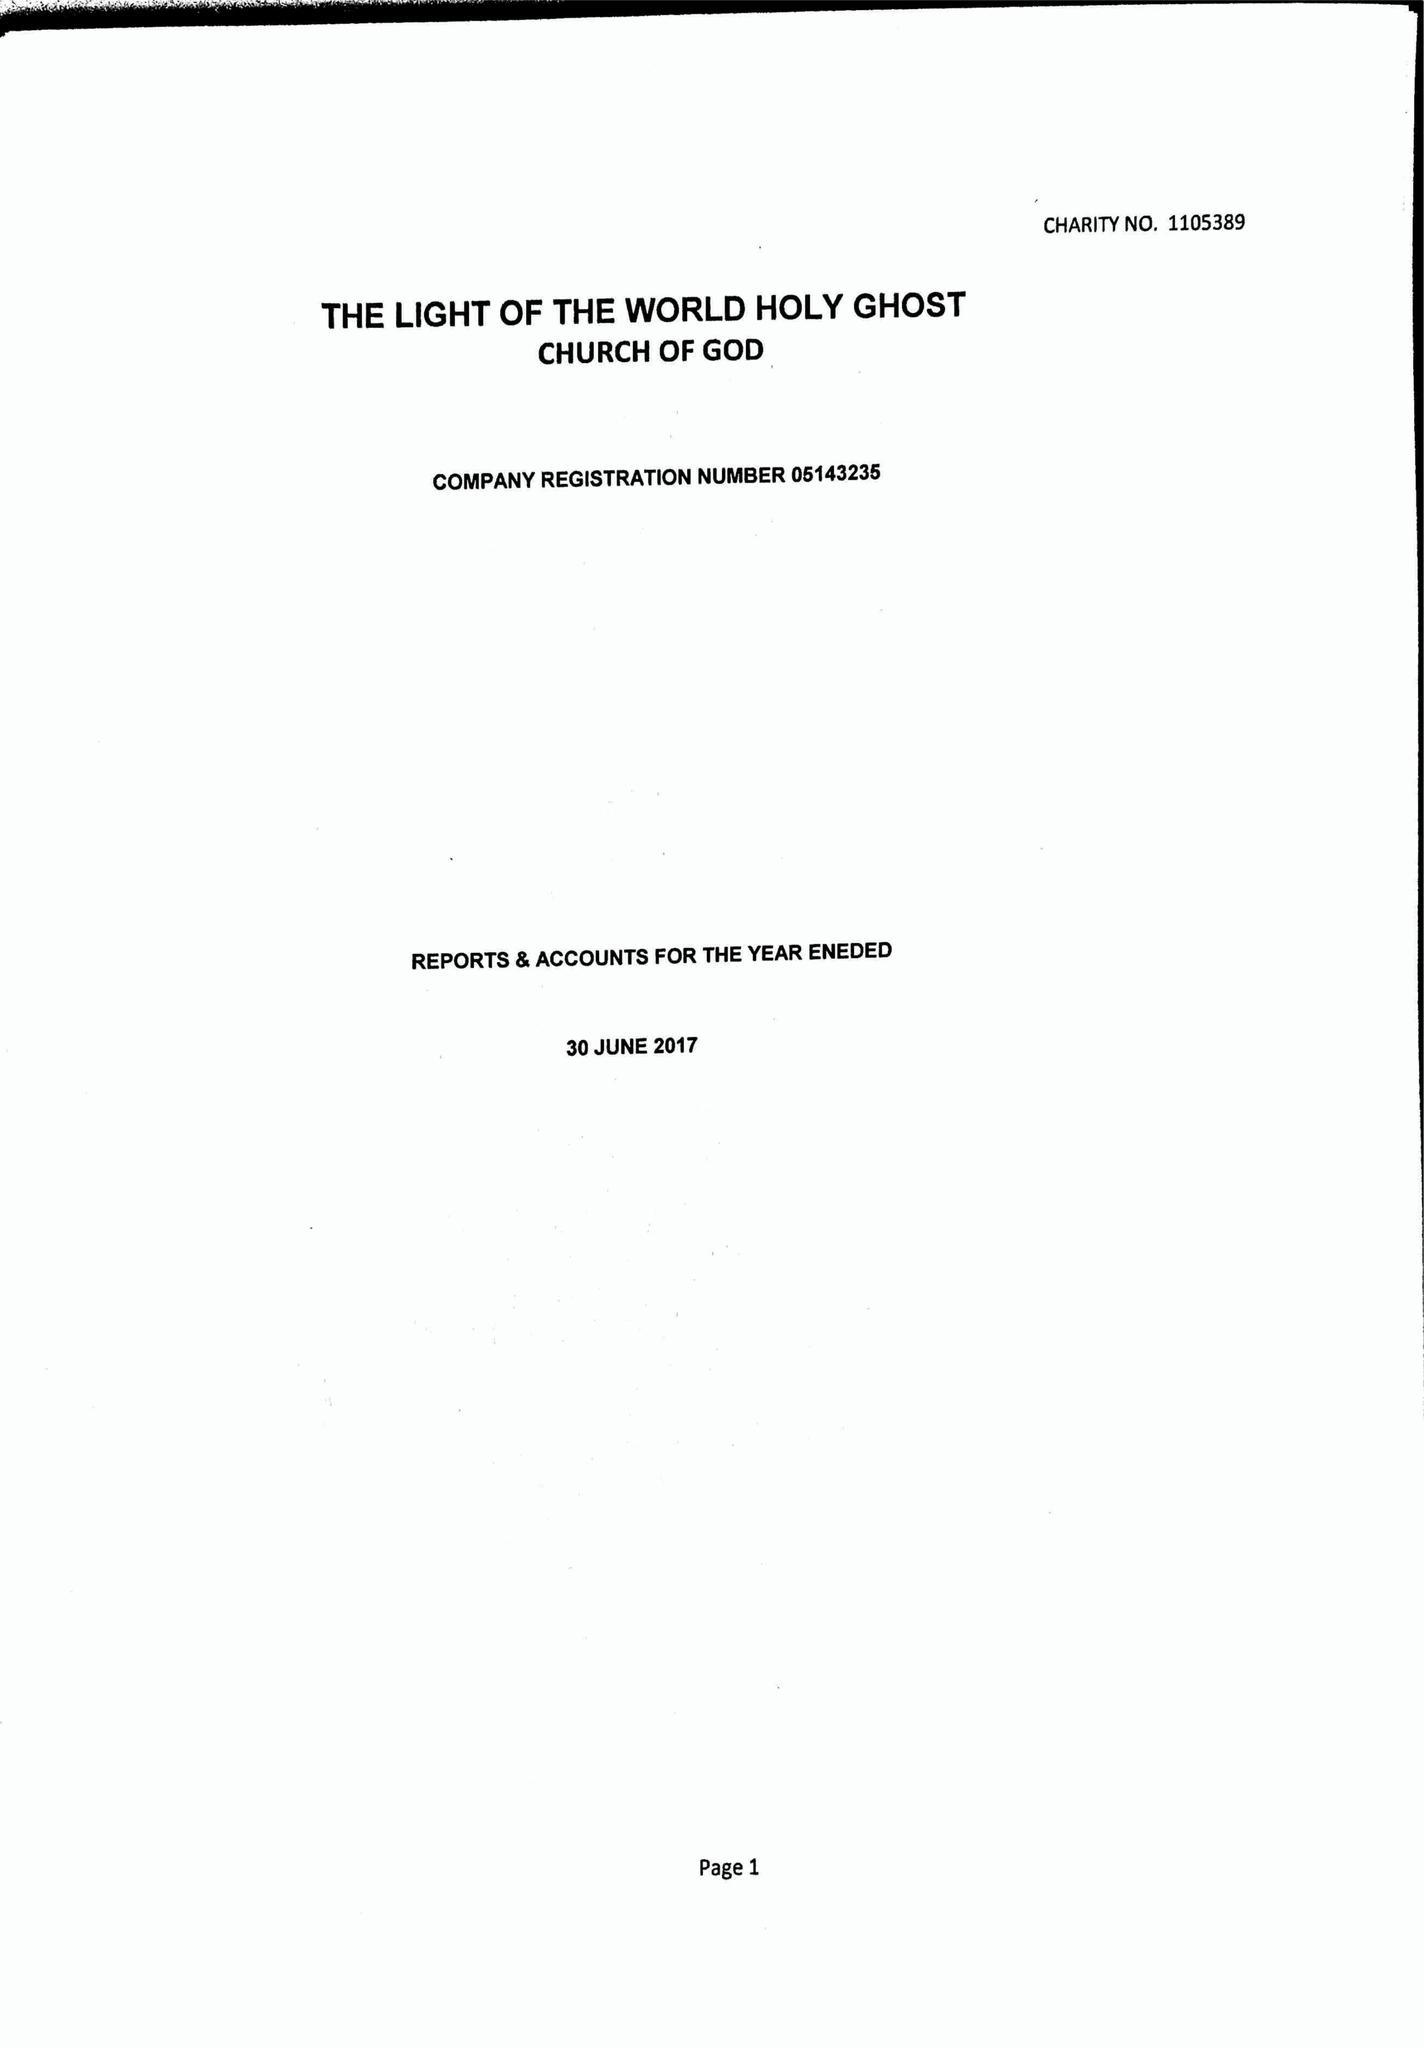What is the value for the charity_number?
Answer the question using a single word or phrase. 1105389 